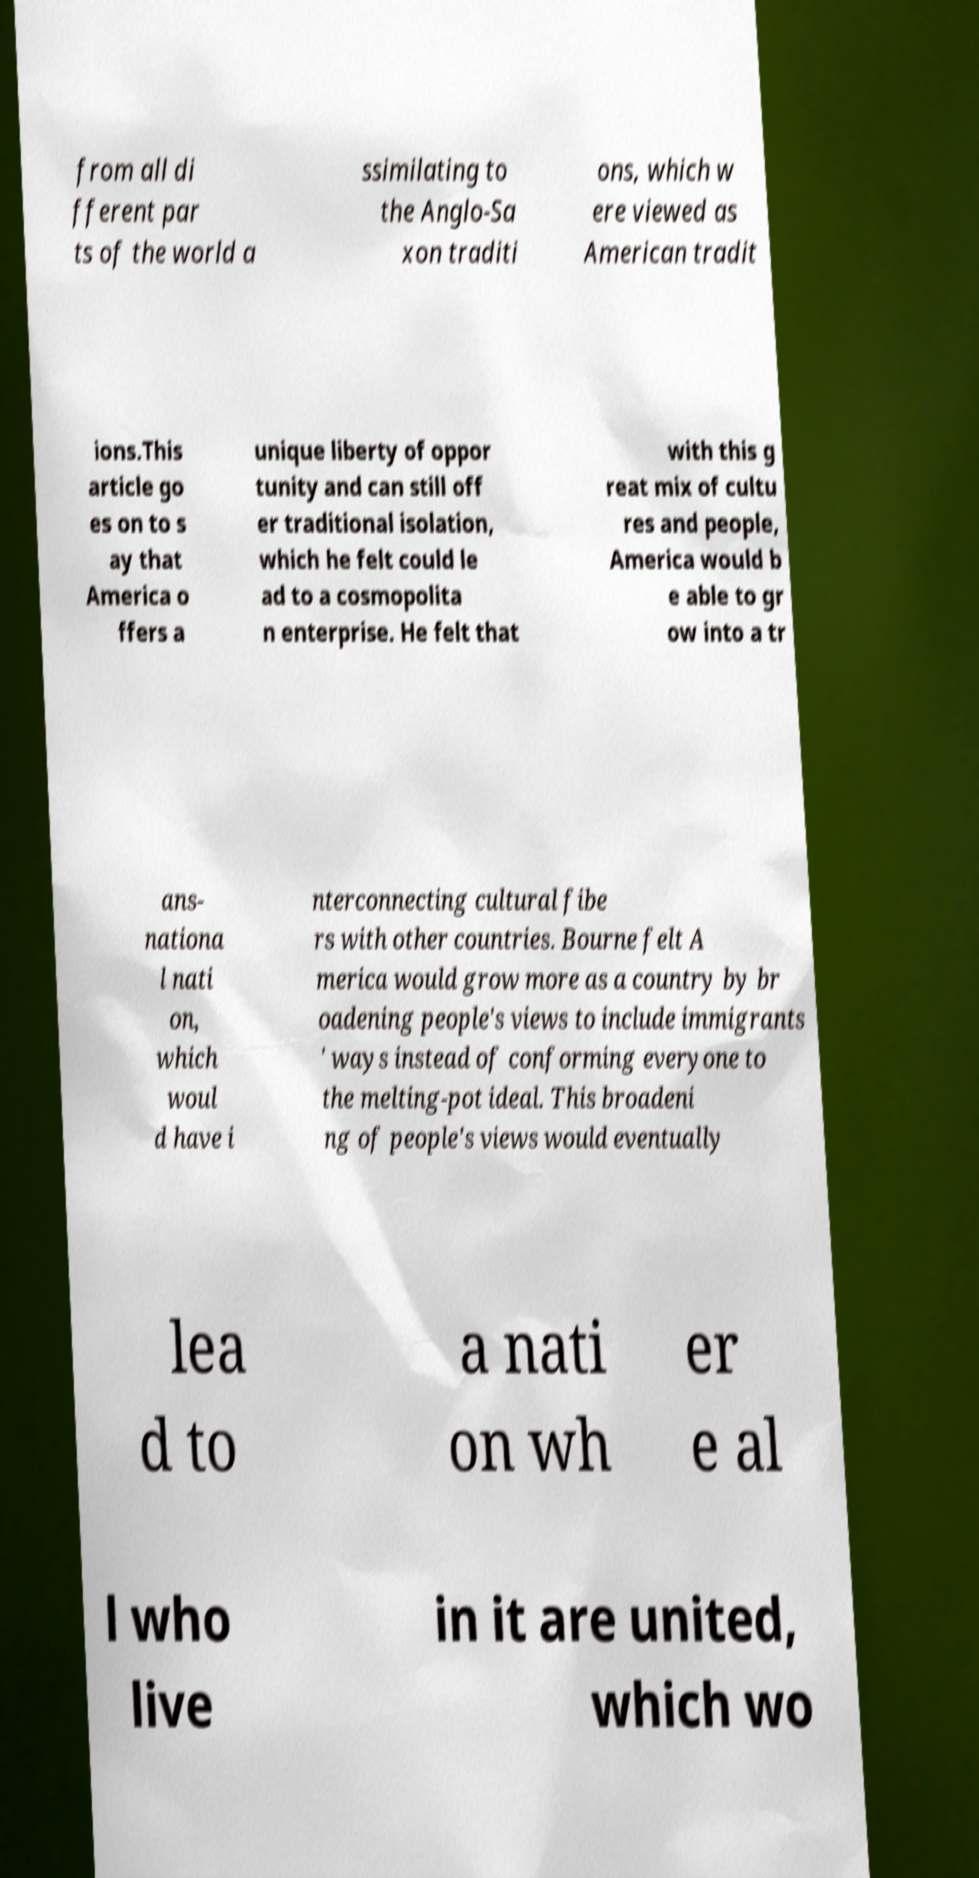There's text embedded in this image that I need extracted. Can you transcribe it verbatim? from all di fferent par ts of the world a ssimilating to the Anglo-Sa xon traditi ons, which w ere viewed as American tradit ions.This article go es on to s ay that America o ffers a unique liberty of oppor tunity and can still off er traditional isolation, which he felt could le ad to a cosmopolita n enterprise. He felt that with this g reat mix of cultu res and people, America would b e able to gr ow into a tr ans- nationa l nati on, which woul d have i nterconnecting cultural fibe rs with other countries. Bourne felt A merica would grow more as a country by br oadening people's views to include immigrants ' ways instead of conforming everyone to the melting-pot ideal. This broadeni ng of people's views would eventually lea d to a nati on wh er e al l who live in it are united, which wo 